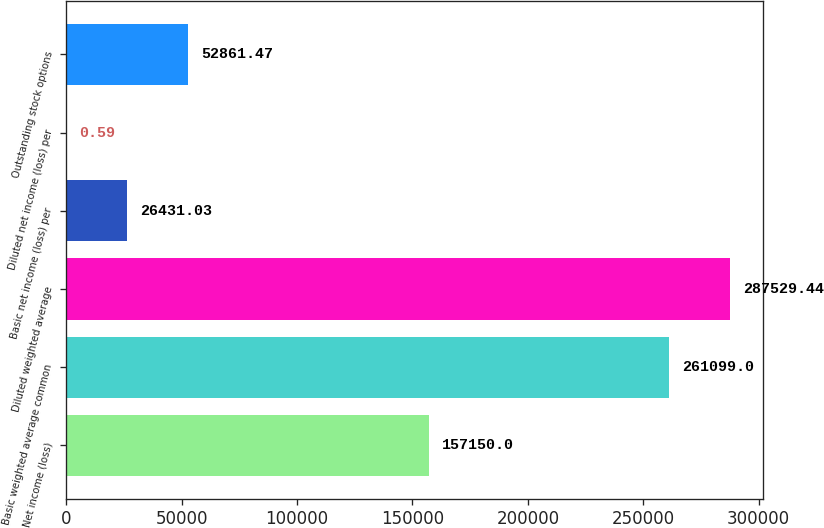<chart> <loc_0><loc_0><loc_500><loc_500><bar_chart><fcel>Net income (loss)<fcel>Basic weighted average common<fcel>Diluted weighted average<fcel>Basic net income (loss) per<fcel>Diluted net income (loss) per<fcel>Outstanding stock options<nl><fcel>157150<fcel>261099<fcel>287529<fcel>26431<fcel>0.59<fcel>52861.5<nl></chart> 